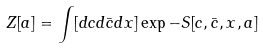<formula> <loc_0><loc_0><loc_500><loc_500>Z [ a ] = \int [ d c d \bar { c } d x ] \exp - S [ c , \bar { c } , x , a ]</formula> 